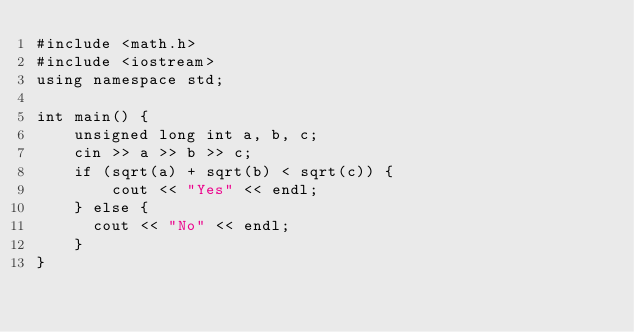Convert code to text. <code><loc_0><loc_0><loc_500><loc_500><_C++_>#include <math.h>
#include <iostream>
using namespace std;

int main() {
    unsigned long int a, b, c;
    cin >> a >> b >> c;
    if (sqrt(a) + sqrt(b) < sqrt(c)) {
        cout << "Yes" << endl;
    } else {
      cout << "No" << endl;
    }
}</code> 